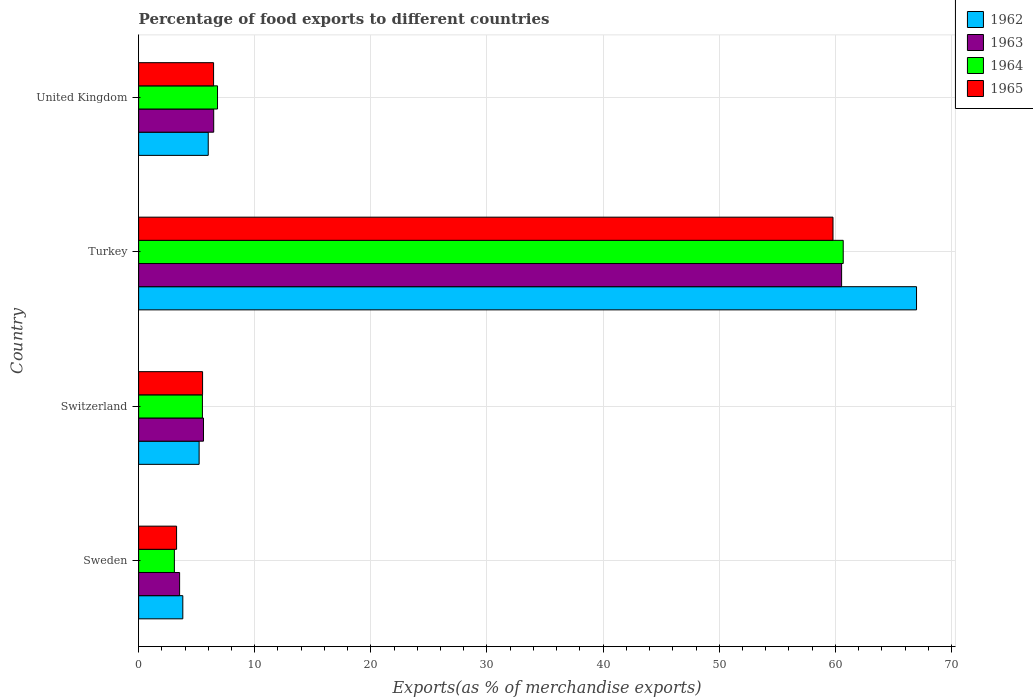How many different coloured bars are there?
Provide a short and direct response. 4. How many groups of bars are there?
Make the answer very short. 4. Are the number of bars per tick equal to the number of legend labels?
Your response must be concise. Yes. How many bars are there on the 1st tick from the bottom?
Your response must be concise. 4. What is the label of the 1st group of bars from the top?
Offer a terse response. United Kingdom. What is the percentage of exports to different countries in 1964 in United Kingdom?
Your response must be concise. 6.79. Across all countries, what is the maximum percentage of exports to different countries in 1964?
Provide a short and direct response. 60.68. Across all countries, what is the minimum percentage of exports to different countries in 1964?
Keep it short and to the point. 3.08. In which country was the percentage of exports to different countries in 1962 minimum?
Give a very brief answer. Sweden. What is the total percentage of exports to different countries in 1962 in the graph?
Your answer should be compact. 82. What is the difference between the percentage of exports to different countries in 1963 in Sweden and that in United Kingdom?
Make the answer very short. -2.94. What is the difference between the percentage of exports to different countries in 1962 in Switzerland and the percentage of exports to different countries in 1965 in United Kingdom?
Your answer should be compact. -1.25. What is the average percentage of exports to different countries in 1963 per country?
Ensure brevity in your answer.  19.03. What is the difference between the percentage of exports to different countries in 1964 and percentage of exports to different countries in 1965 in United Kingdom?
Provide a succinct answer. 0.34. What is the ratio of the percentage of exports to different countries in 1962 in Turkey to that in United Kingdom?
Ensure brevity in your answer.  11.18. Is the percentage of exports to different countries in 1963 in Sweden less than that in Switzerland?
Your answer should be compact. Yes. Is the difference between the percentage of exports to different countries in 1964 in Sweden and Turkey greater than the difference between the percentage of exports to different countries in 1965 in Sweden and Turkey?
Offer a terse response. No. What is the difference between the highest and the second highest percentage of exports to different countries in 1962?
Offer a very short reply. 61. What is the difference between the highest and the lowest percentage of exports to different countries in 1963?
Keep it short and to the point. 57.01. What does the 4th bar from the top in Sweden represents?
Ensure brevity in your answer.  1962. What does the 3rd bar from the bottom in Turkey represents?
Make the answer very short. 1964. Is it the case that in every country, the sum of the percentage of exports to different countries in 1962 and percentage of exports to different countries in 1965 is greater than the percentage of exports to different countries in 1964?
Offer a terse response. Yes. How many countries are there in the graph?
Your answer should be very brief. 4. Does the graph contain any zero values?
Keep it short and to the point. No. Does the graph contain grids?
Provide a short and direct response. Yes. How are the legend labels stacked?
Your response must be concise. Vertical. What is the title of the graph?
Provide a succinct answer. Percentage of food exports to different countries. What is the label or title of the X-axis?
Your answer should be compact. Exports(as % of merchandise exports). What is the label or title of the Y-axis?
Ensure brevity in your answer.  Country. What is the Exports(as % of merchandise exports) in 1962 in Sweden?
Offer a terse response. 3.8. What is the Exports(as % of merchandise exports) in 1963 in Sweden?
Provide a succinct answer. 3.53. What is the Exports(as % of merchandise exports) of 1964 in Sweden?
Your answer should be very brief. 3.08. What is the Exports(as % of merchandise exports) of 1965 in Sweden?
Your answer should be very brief. 3.27. What is the Exports(as % of merchandise exports) in 1962 in Switzerland?
Make the answer very short. 5.21. What is the Exports(as % of merchandise exports) in 1963 in Switzerland?
Give a very brief answer. 5.59. What is the Exports(as % of merchandise exports) in 1964 in Switzerland?
Ensure brevity in your answer.  5.49. What is the Exports(as % of merchandise exports) in 1965 in Switzerland?
Keep it short and to the point. 5.51. What is the Exports(as % of merchandise exports) of 1962 in Turkey?
Your answer should be compact. 66.99. What is the Exports(as % of merchandise exports) of 1963 in Turkey?
Provide a succinct answer. 60.54. What is the Exports(as % of merchandise exports) in 1964 in Turkey?
Provide a succinct answer. 60.68. What is the Exports(as % of merchandise exports) of 1965 in Turkey?
Provide a short and direct response. 59.8. What is the Exports(as % of merchandise exports) in 1962 in United Kingdom?
Ensure brevity in your answer.  5.99. What is the Exports(as % of merchandise exports) of 1963 in United Kingdom?
Provide a succinct answer. 6.47. What is the Exports(as % of merchandise exports) of 1964 in United Kingdom?
Offer a terse response. 6.79. What is the Exports(as % of merchandise exports) of 1965 in United Kingdom?
Your answer should be compact. 6.45. Across all countries, what is the maximum Exports(as % of merchandise exports) of 1962?
Provide a short and direct response. 66.99. Across all countries, what is the maximum Exports(as % of merchandise exports) in 1963?
Provide a short and direct response. 60.54. Across all countries, what is the maximum Exports(as % of merchandise exports) in 1964?
Offer a very short reply. 60.68. Across all countries, what is the maximum Exports(as % of merchandise exports) of 1965?
Keep it short and to the point. 59.8. Across all countries, what is the minimum Exports(as % of merchandise exports) of 1962?
Ensure brevity in your answer.  3.8. Across all countries, what is the minimum Exports(as % of merchandise exports) in 1963?
Keep it short and to the point. 3.53. Across all countries, what is the minimum Exports(as % of merchandise exports) of 1964?
Your response must be concise. 3.08. Across all countries, what is the minimum Exports(as % of merchandise exports) of 1965?
Give a very brief answer. 3.27. What is the total Exports(as % of merchandise exports) in 1962 in the graph?
Your response must be concise. 82. What is the total Exports(as % of merchandise exports) of 1963 in the graph?
Give a very brief answer. 76.12. What is the total Exports(as % of merchandise exports) in 1964 in the graph?
Give a very brief answer. 76.04. What is the total Exports(as % of merchandise exports) of 1965 in the graph?
Offer a very short reply. 75.03. What is the difference between the Exports(as % of merchandise exports) in 1962 in Sweden and that in Switzerland?
Provide a succinct answer. -1.4. What is the difference between the Exports(as % of merchandise exports) in 1963 in Sweden and that in Switzerland?
Your answer should be compact. -2.06. What is the difference between the Exports(as % of merchandise exports) of 1964 in Sweden and that in Switzerland?
Give a very brief answer. -2.41. What is the difference between the Exports(as % of merchandise exports) of 1965 in Sweden and that in Switzerland?
Your answer should be compact. -2.24. What is the difference between the Exports(as % of merchandise exports) in 1962 in Sweden and that in Turkey?
Give a very brief answer. -63.19. What is the difference between the Exports(as % of merchandise exports) in 1963 in Sweden and that in Turkey?
Offer a terse response. -57.01. What is the difference between the Exports(as % of merchandise exports) of 1964 in Sweden and that in Turkey?
Your response must be concise. -57.6. What is the difference between the Exports(as % of merchandise exports) of 1965 in Sweden and that in Turkey?
Your answer should be compact. -56.53. What is the difference between the Exports(as % of merchandise exports) in 1962 in Sweden and that in United Kingdom?
Your response must be concise. -2.19. What is the difference between the Exports(as % of merchandise exports) of 1963 in Sweden and that in United Kingdom?
Offer a very short reply. -2.94. What is the difference between the Exports(as % of merchandise exports) of 1964 in Sweden and that in United Kingdom?
Provide a short and direct response. -3.71. What is the difference between the Exports(as % of merchandise exports) of 1965 in Sweden and that in United Kingdom?
Your response must be concise. -3.19. What is the difference between the Exports(as % of merchandise exports) of 1962 in Switzerland and that in Turkey?
Offer a terse response. -61.78. What is the difference between the Exports(as % of merchandise exports) of 1963 in Switzerland and that in Turkey?
Your answer should be very brief. -54.96. What is the difference between the Exports(as % of merchandise exports) in 1964 in Switzerland and that in Turkey?
Keep it short and to the point. -55.18. What is the difference between the Exports(as % of merchandise exports) in 1965 in Switzerland and that in Turkey?
Ensure brevity in your answer.  -54.29. What is the difference between the Exports(as % of merchandise exports) in 1962 in Switzerland and that in United Kingdom?
Your answer should be very brief. -0.78. What is the difference between the Exports(as % of merchandise exports) of 1963 in Switzerland and that in United Kingdom?
Keep it short and to the point. -0.88. What is the difference between the Exports(as % of merchandise exports) of 1965 in Switzerland and that in United Kingdom?
Offer a very short reply. -0.95. What is the difference between the Exports(as % of merchandise exports) in 1962 in Turkey and that in United Kingdom?
Your answer should be compact. 61. What is the difference between the Exports(as % of merchandise exports) of 1963 in Turkey and that in United Kingdom?
Offer a terse response. 54.08. What is the difference between the Exports(as % of merchandise exports) of 1964 in Turkey and that in United Kingdom?
Keep it short and to the point. 53.88. What is the difference between the Exports(as % of merchandise exports) in 1965 in Turkey and that in United Kingdom?
Offer a very short reply. 53.34. What is the difference between the Exports(as % of merchandise exports) in 1962 in Sweden and the Exports(as % of merchandise exports) in 1963 in Switzerland?
Make the answer very short. -1.78. What is the difference between the Exports(as % of merchandise exports) of 1962 in Sweden and the Exports(as % of merchandise exports) of 1964 in Switzerland?
Ensure brevity in your answer.  -1.69. What is the difference between the Exports(as % of merchandise exports) in 1962 in Sweden and the Exports(as % of merchandise exports) in 1965 in Switzerland?
Provide a succinct answer. -1.7. What is the difference between the Exports(as % of merchandise exports) of 1963 in Sweden and the Exports(as % of merchandise exports) of 1964 in Switzerland?
Give a very brief answer. -1.96. What is the difference between the Exports(as % of merchandise exports) in 1963 in Sweden and the Exports(as % of merchandise exports) in 1965 in Switzerland?
Your answer should be very brief. -1.98. What is the difference between the Exports(as % of merchandise exports) in 1964 in Sweden and the Exports(as % of merchandise exports) in 1965 in Switzerland?
Your answer should be compact. -2.43. What is the difference between the Exports(as % of merchandise exports) in 1962 in Sweden and the Exports(as % of merchandise exports) in 1963 in Turkey?
Provide a short and direct response. -56.74. What is the difference between the Exports(as % of merchandise exports) of 1962 in Sweden and the Exports(as % of merchandise exports) of 1964 in Turkey?
Provide a succinct answer. -56.87. What is the difference between the Exports(as % of merchandise exports) in 1962 in Sweden and the Exports(as % of merchandise exports) in 1965 in Turkey?
Provide a succinct answer. -55.99. What is the difference between the Exports(as % of merchandise exports) of 1963 in Sweden and the Exports(as % of merchandise exports) of 1964 in Turkey?
Your answer should be very brief. -57.15. What is the difference between the Exports(as % of merchandise exports) of 1963 in Sweden and the Exports(as % of merchandise exports) of 1965 in Turkey?
Make the answer very short. -56.27. What is the difference between the Exports(as % of merchandise exports) of 1964 in Sweden and the Exports(as % of merchandise exports) of 1965 in Turkey?
Provide a succinct answer. -56.72. What is the difference between the Exports(as % of merchandise exports) of 1962 in Sweden and the Exports(as % of merchandise exports) of 1963 in United Kingdom?
Ensure brevity in your answer.  -2.66. What is the difference between the Exports(as % of merchandise exports) of 1962 in Sweden and the Exports(as % of merchandise exports) of 1964 in United Kingdom?
Keep it short and to the point. -2.99. What is the difference between the Exports(as % of merchandise exports) of 1962 in Sweden and the Exports(as % of merchandise exports) of 1965 in United Kingdom?
Offer a terse response. -2.65. What is the difference between the Exports(as % of merchandise exports) of 1963 in Sweden and the Exports(as % of merchandise exports) of 1964 in United Kingdom?
Give a very brief answer. -3.26. What is the difference between the Exports(as % of merchandise exports) of 1963 in Sweden and the Exports(as % of merchandise exports) of 1965 in United Kingdom?
Give a very brief answer. -2.93. What is the difference between the Exports(as % of merchandise exports) of 1964 in Sweden and the Exports(as % of merchandise exports) of 1965 in United Kingdom?
Give a very brief answer. -3.38. What is the difference between the Exports(as % of merchandise exports) in 1962 in Switzerland and the Exports(as % of merchandise exports) in 1963 in Turkey?
Give a very brief answer. -55.33. What is the difference between the Exports(as % of merchandise exports) of 1962 in Switzerland and the Exports(as % of merchandise exports) of 1964 in Turkey?
Give a very brief answer. -55.47. What is the difference between the Exports(as % of merchandise exports) of 1962 in Switzerland and the Exports(as % of merchandise exports) of 1965 in Turkey?
Your answer should be very brief. -54.59. What is the difference between the Exports(as % of merchandise exports) of 1963 in Switzerland and the Exports(as % of merchandise exports) of 1964 in Turkey?
Give a very brief answer. -55.09. What is the difference between the Exports(as % of merchandise exports) in 1963 in Switzerland and the Exports(as % of merchandise exports) in 1965 in Turkey?
Provide a succinct answer. -54.21. What is the difference between the Exports(as % of merchandise exports) of 1964 in Switzerland and the Exports(as % of merchandise exports) of 1965 in Turkey?
Your answer should be very brief. -54.31. What is the difference between the Exports(as % of merchandise exports) in 1962 in Switzerland and the Exports(as % of merchandise exports) in 1963 in United Kingdom?
Your response must be concise. -1.26. What is the difference between the Exports(as % of merchandise exports) of 1962 in Switzerland and the Exports(as % of merchandise exports) of 1964 in United Kingdom?
Your answer should be compact. -1.58. What is the difference between the Exports(as % of merchandise exports) of 1962 in Switzerland and the Exports(as % of merchandise exports) of 1965 in United Kingdom?
Give a very brief answer. -1.25. What is the difference between the Exports(as % of merchandise exports) in 1963 in Switzerland and the Exports(as % of merchandise exports) in 1964 in United Kingdom?
Make the answer very short. -1.21. What is the difference between the Exports(as % of merchandise exports) of 1963 in Switzerland and the Exports(as % of merchandise exports) of 1965 in United Kingdom?
Ensure brevity in your answer.  -0.87. What is the difference between the Exports(as % of merchandise exports) of 1964 in Switzerland and the Exports(as % of merchandise exports) of 1965 in United Kingdom?
Your answer should be compact. -0.96. What is the difference between the Exports(as % of merchandise exports) of 1962 in Turkey and the Exports(as % of merchandise exports) of 1963 in United Kingdom?
Provide a short and direct response. 60.53. What is the difference between the Exports(as % of merchandise exports) in 1962 in Turkey and the Exports(as % of merchandise exports) in 1964 in United Kingdom?
Keep it short and to the point. 60.2. What is the difference between the Exports(as % of merchandise exports) in 1962 in Turkey and the Exports(as % of merchandise exports) in 1965 in United Kingdom?
Keep it short and to the point. 60.54. What is the difference between the Exports(as % of merchandise exports) of 1963 in Turkey and the Exports(as % of merchandise exports) of 1964 in United Kingdom?
Give a very brief answer. 53.75. What is the difference between the Exports(as % of merchandise exports) of 1963 in Turkey and the Exports(as % of merchandise exports) of 1965 in United Kingdom?
Offer a very short reply. 54.09. What is the difference between the Exports(as % of merchandise exports) of 1964 in Turkey and the Exports(as % of merchandise exports) of 1965 in United Kingdom?
Make the answer very short. 54.22. What is the average Exports(as % of merchandise exports) in 1962 per country?
Your answer should be very brief. 20.5. What is the average Exports(as % of merchandise exports) in 1963 per country?
Ensure brevity in your answer.  19.03. What is the average Exports(as % of merchandise exports) in 1964 per country?
Offer a terse response. 19.01. What is the average Exports(as % of merchandise exports) of 1965 per country?
Your answer should be very brief. 18.76. What is the difference between the Exports(as % of merchandise exports) of 1962 and Exports(as % of merchandise exports) of 1963 in Sweden?
Ensure brevity in your answer.  0.28. What is the difference between the Exports(as % of merchandise exports) of 1962 and Exports(as % of merchandise exports) of 1964 in Sweden?
Your response must be concise. 0.73. What is the difference between the Exports(as % of merchandise exports) of 1962 and Exports(as % of merchandise exports) of 1965 in Sweden?
Your answer should be compact. 0.54. What is the difference between the Exports(as % of merchandise exports) of 1963 and Exports(as % of merchandise exports) of 1964 in Sweden?
Offer a terse response. 0.45. What is the difference between the Exports(as % of merchandise exports) in 1963 and Exports(as % of merchandise exports) in 1965 in Sweden?
Offer a very short reply. 0.26. What is the difference between the Exports(as % of merchandise exports) in 1964 and Exports(as % of merchandise exports) in 1965 in Sweden?
Give a very brief answer. -0.19. What is the difference between the Exports(as % of merchandise exports) of 1962 and Exports(as % of merchandise exports) of 1963 in Switzerland?
Give a very brief answer. -0.38. What is the difference between the Exports(as % of merchandise exports) of 1962 and Exports(as % of merchandise exports) of 1964 in Switzerland?
Offer a terse response. -0.28. What is the difference between the Exports(as % of merchandise exports) of 1962 and Exports(as % of merchandise exports) of 1965 in Switzerland?
Offer a very short reply. -0.3. What is the difference between the Exports(as % of merchandise exports) in 1963 and Exports(as % of merchandise exports) in 1964 in Switzerland?
Provide a short and direct response. 0.09. What is the difference between the Exports(as % of merchandise exports) in 1963 and Exports(as % of merchandise exports) in 1965 in Switzerland?
Give a very brief answer. 0.08. What is the difference between the Exports(as % of merchandise exports) of 1964 and Exports(as % of merchandise exports) of 1965 in Switzerland?
Make the answer very short. -0.01. What is the difference between the Exports(as % of merchandise exports) of 1962 and Exports(as % of merchandise exports) of 1963 in Turkey?
Offer a very short reply. 6.45. What is the difference between the Exports(as % of merchandise exports) of 1962 and Exports(as % of merchandise exports) of 1964 in Turkey?
Provide a succinct answer. 6.31. What is the difference between the Exports(as % of merchandise exports) of 1962 and Exports(as % of merchandise exports) of 1965 in Turkey?
Your response must be concise. 7.19. What is the difference between the Exports(as % of merchandise exports) of 1963 and Exports(as % of merchandise exports) of 1964 in Turkey?
Ensure brevity in your answer.  -0.14. What is the difference between the Exports(as % of merchandise exports) in 1963 and Exports(as % of merchandise exports) in 1965 in Turkey?
Provide a short and direct response. 0.74. What is the difference between the Exports(as % of merchandise exports) of 1964 and Exports(as % of merchandise exports) of 1965 in Turkey?
Keep it short and to the point. 0.88. What is the difference between the Exports(as % of merchandise exports) of 1962 and Exports(as % of merchandise exports) of 1963 in United Kingdom?
Offer a terse response. -0.47. What is the difference between the Exports(as % of merchandise exports) of 1962 and Exports(as % of merchandise exports) of 1964 in United Kingdom?
Offer a very short reply. -0.8. What is the difference between the Exports(as % of merchandise exports) of 1962 and Exports(as % of merchandise exports) of 1965 in United Kingdom?
Make the answer very short. -0.46. What is the difference between the Exports(as % of merchandise exports) of 1963 and Exports(as % of merchandise exports) of 1964 in United Kingdom?
Ensure brevity in your answer.  -0.33. What is the difference between the Exports(as % of merchandise exports) of 1963 and Exports(as % of merchandise exports) of 1965 in United Kingdom?
Offer a very short reply. 0.01. What is the difference between the Exports(as % of merchandise exports) in 1964 and Exports(as % of merchandise exports) in 1965 in United Kingdom?
Offer a very short reply. 0.34. What is the ratio of the Exports(as % of merchandise exports) of 1962 in Sweden to that in Switzerland?
Keep it short and to the point. 0.73. What is the ratio of the Exports(as % of merchandise exports) of 1963 in Sweden to that in Switzerland?
Make the answer very short. 0.63. What is the ratio of the Exports(as % of merchandise exports) in 1964 in Sweden to that in Switzerland?
Your response must be concise. 0.56. What is the ratio of the Exports(as % of merchandise exports) of 1965 in Sweden to that in Switzerland?
Provide a succinct answer. 0.59. What is the ratio of the Exports(as % of merchandise exports) in 1962 in Sweden to that in Turkey?
Offer a terse response. 0.06. What is the ratio of the Exports(as % of merchandise exports) of 1963 in Sweden to that in Turkey?
Your answer should be compact. 0.06. What is the ratio of the Exports(as % of merchandise exports) in 1964 in Sweden to that in Turkey?
Ensure brevity in your answer.  0.05. What is the ratio of the Exports(as % of merchandise exports) in 1965 in Sweden to that in Turkey?
Offer a very short reply. 0.05. What is the ratio of the Exports(as % of merchandise exports) of 1962 in Sweden to that in United Kingdom?
Keep it short and to the point. 0.63. What is the ratio of the Exports(as % of merchandise exports) of 1963 in Sweden to that in United Kingdom?
Offer a very short reply. 0.55. What is the ratio of the Exports(as % of merchandise exports) in 1964 in Sweden to that in United Kingdom?
Make the answer very short. 0.45. What is the ratio of the Exports(as % of merchandise exports) of 1965 in Sweden to that in United Kingdom?
Your response must be concise. 0.51. What is the ratio of the Exports(as % of merchandise exports) of 1962 in Switzerland to that in Turkey?
Ensure brevity in your answer.  0.08. What is the ratio of the Exports(as % of merchandise exports) in 1963 in Switzerland to that in Turkey?
Ensure brevity in your answer.  0.09. What is the ratio of the Exports(as % of merchandise exports) in 1964 in Switzerland to that in Turkey?
Offer a very short reply. 0.09. What is the ratio of the Exports(as % of merchandise exports) in 1965 in Switzerland to that in Turkey?
Your answer should be compact. 0.09. What is the ratio of the Exports(as % of merchandise exports) in 1962 in Switzerland to that in United Kingdom?
Ensure brevity in your answer.  0.87. What is the ratio of the Exports(as % of merchandise exports) of 1963 in Switzerland to that in United Kingdom?
Your answer should be compact. 0.86. What is the ratio of the Exports(as % of merchandise exports) in 1964 in Switzerland to that in United Kingdom?
Offer a terse response. 0.81. What is the ratio of the Exports(as % of merchandise exports) in 1965 in Switzerland to that in United Kingdom?
Give a very brief answer. 0.85. What is the ratio of the Exports(as % of merchandise exports) of 1962 in Turkey to that in United Kingdom?
Offer a terse response. 11.18. What is the ratio of the Exports(as % of merchandise exports) in 1963 in Turkey to that in United Kingdom?
Offer a terse response. 9.36. What is the ratio of the Exports(as % of merchandise exports) in 1964 in Turkey to that in United Kingdom?
Your response must be concise. 8.93. What is the ratio of the Exports(as % of merchandise exports) in 1965 in Turkey to that in United Kingdom?
Offer a terse response. 9.26. What is the difference between the highest and the second highest Exports(as % of merchandise exports) in 1962?
Keep it short and to the point. 61. What is the difference between the highest and the second highest Exports(as % of merchandise exports) of 1963?
Provide a succinct answer. 54.08. What is the difference between the highest and the second highest Exports(as % of merchandise exports) in 1964?
Offer a very short reply. 53.88. What is the difference between the highest and the second highest Exports(as % of merchandise exports) of 1965?
Ensure brevity in your answer.  53.34. What is the difference between the highest and the lowest Exports(as % of merchandise exports) of 1962?
Your response must be concise. 63.19. What is the difference between the highest and the lowest Exports(as % of merchandise exports) of 1963?
Your response must be concise. 57.01. What is the difference between the highest and the lowest Exports(as % of merchandise exports) of 1964?
Ensure brevity in your answer.  57.6. What is the difference between the highest and the lowest Exports(as % of merchandise exports) of 1965?
Provide a short and direct response. 56.53. 